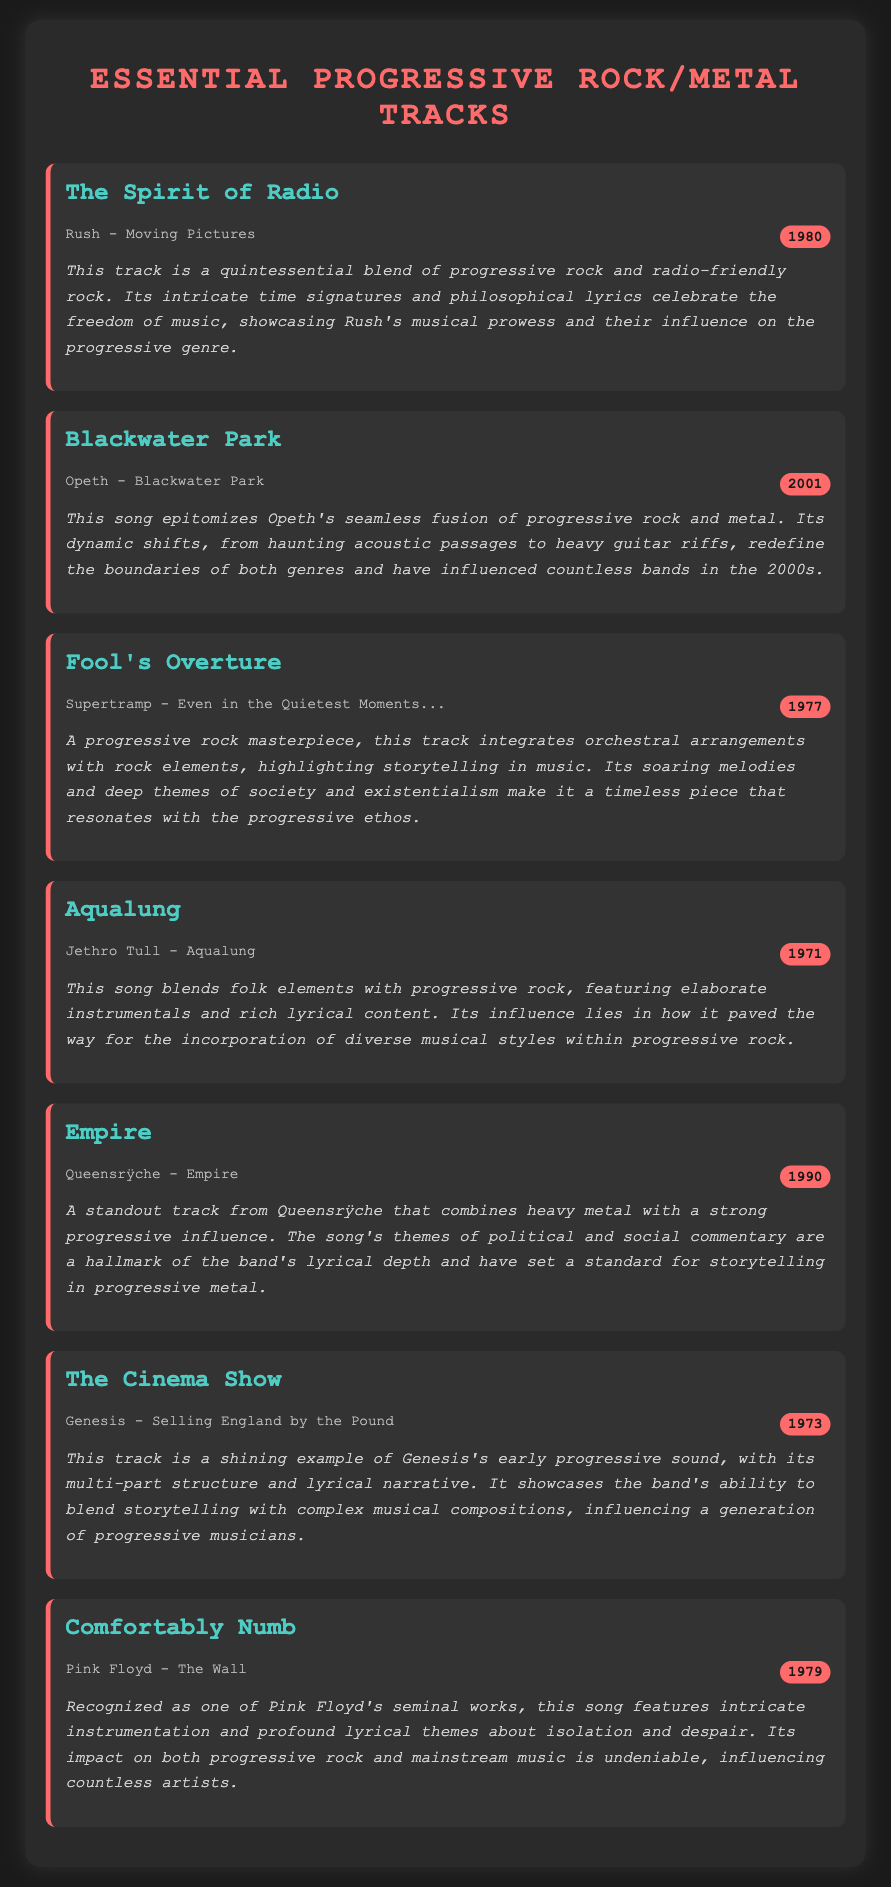what is the title of the first track? The title of the first track listed in the document is "The Spirit of Radio."
Answer: The Spirit of Radio who is the artist for the track "Blackwater Park"? The artist for "Blackwater Park" is given in the document as Opeth.
Answer: Opeth which year was "Comfortably Numb" released? The year mentioned for the release of "Comfortably Numb" is 1979.
Answer: 1979 how many tracks are listed in the document? The total number of tracks present in the playlist is seven, as deduced from the segments.
Answer: seven what genre does "Empire" by Queensrÿche belong to? The genre indicated for "Empire" is progressive metal, as stated in the commentary.
Answer: progressive metal which track features orchestral arrangements? The track that integrates orchestral arrangements is "Fool's Overture."
Answer: Fool's Overture who wrote the song "Aqualung"? The writer mentioned for the song "Aqualung" is Jethro Tull.
Answer: Jethro Tull which band has a track titled "The Cinema Show"? The band with a track titled "The Cinema Show" is Genesis.
Answer: Genesis 